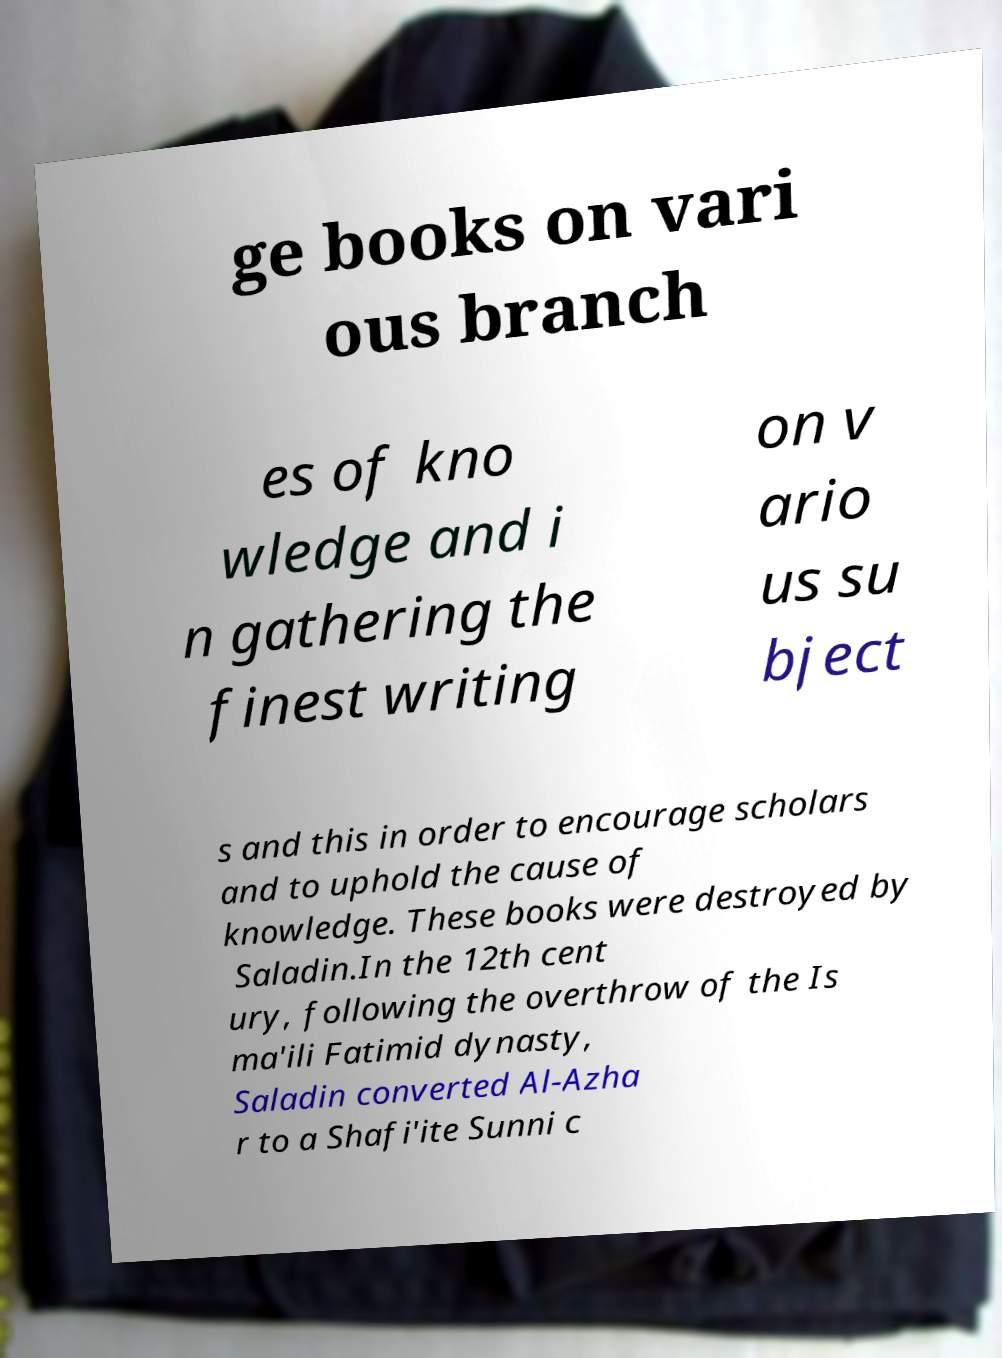I need the written content from this picture converted into text. Can you do that? ge books on vari ous branch es of kno wledge and i n gathering the finest writing on v ario us su bject s and this in order to encourage scholars and to uphold the cause of knowledge. These books were destroyed by Saladin.In the 12th cent ury, following the overthrow of the Is ma'ili Fatimid dynasty, Saladin converted Al-Azha r to a Shafi'ite Sunni c 